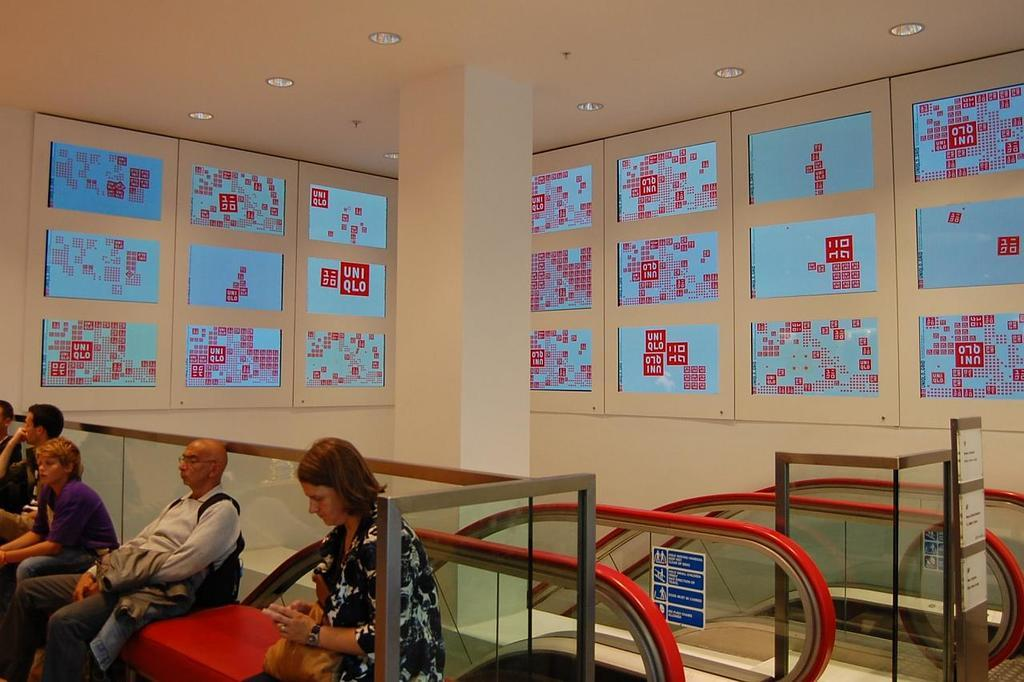What are the people in the image doing? The people in the image are sitting on a bench. What architectural feature is present in the image? There are escalators present in the image. What is written on the wall in the image? There are banners with text on the wall in the image. What can be seen providing illumination in the image? There are lights visible in the image. How many sheep are visible in the image? There are no sheep present in the image. What type of mice can be seen interacting with the people on the bench? There are no mice present in the image; the people are sitting on the bench without any interaction with animals. 